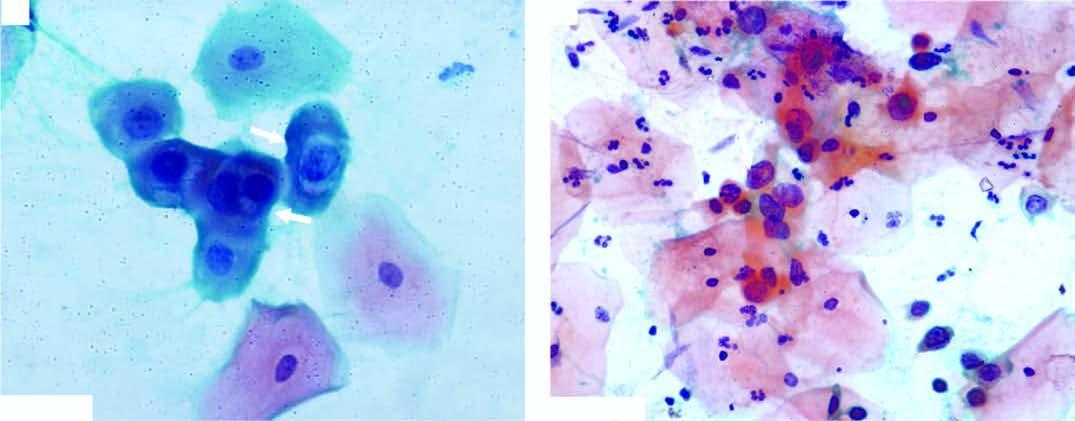what did scanty cytoplasm and markedly hyperchromatic nuclei have?
Answer the question using a single word or phrase. Irregular nuclear outlines 